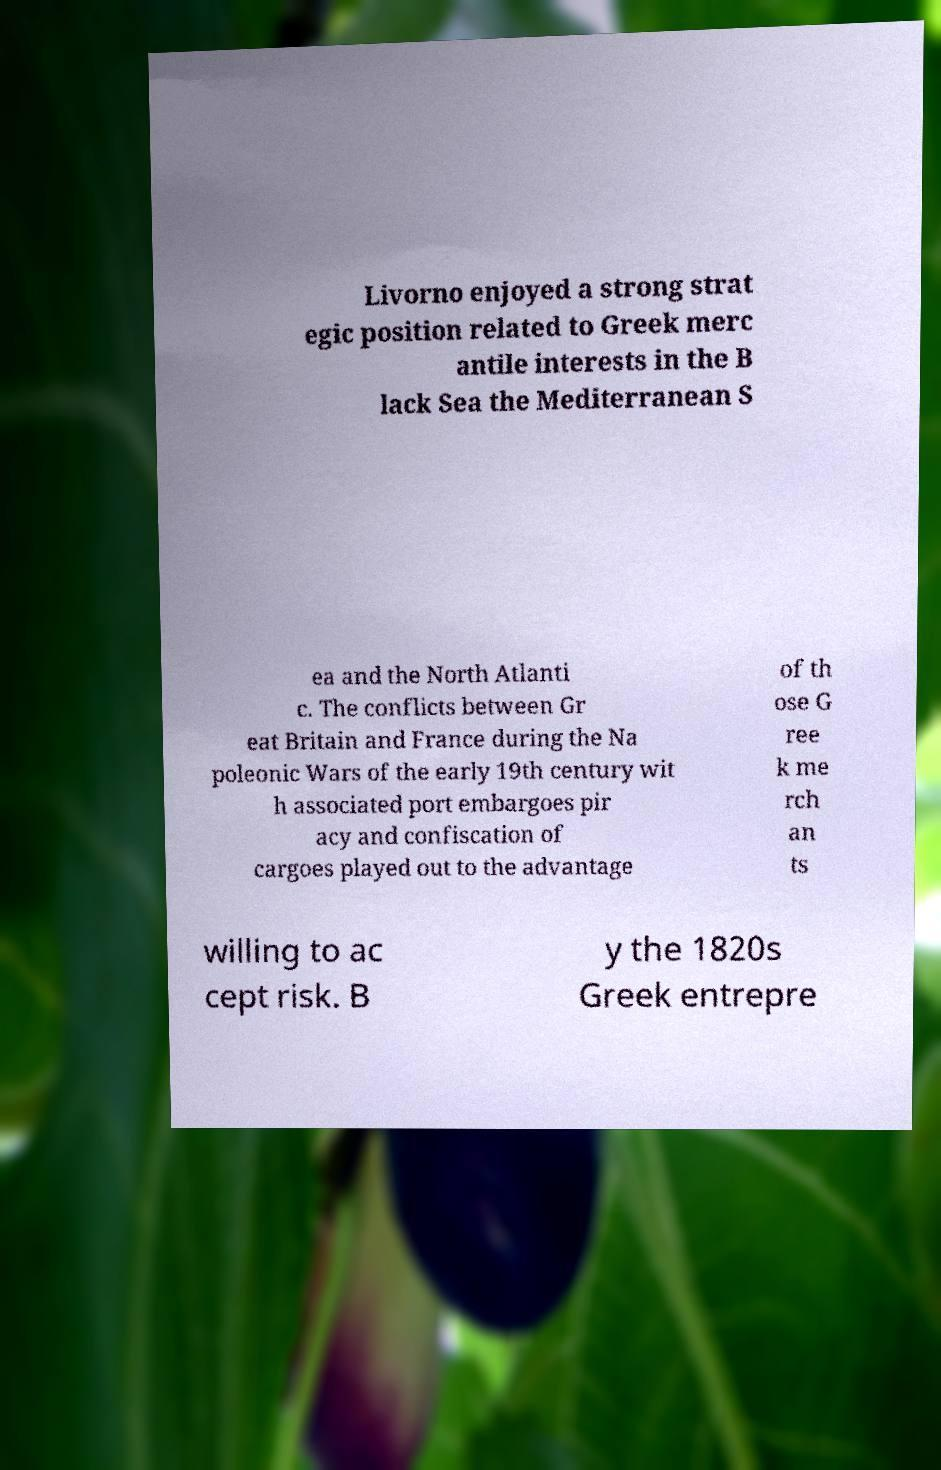Please read and relay the text visible in this image. What does it say? Livorno enjoyed a strong strat egic position related to Greek merc antile interests in the B lack Sea the Mediterranean S ea and the North Atlanti c. The conflicts between Gr eat Britain and France during the Na poleonic Wars of the early 19th century wit h associated port embargoes pir acy and confiscation of cargoes played out to the advantage of th ose G ree k me rch an ts willing to ac cept risk. B y the 1820s Greek entrepre 